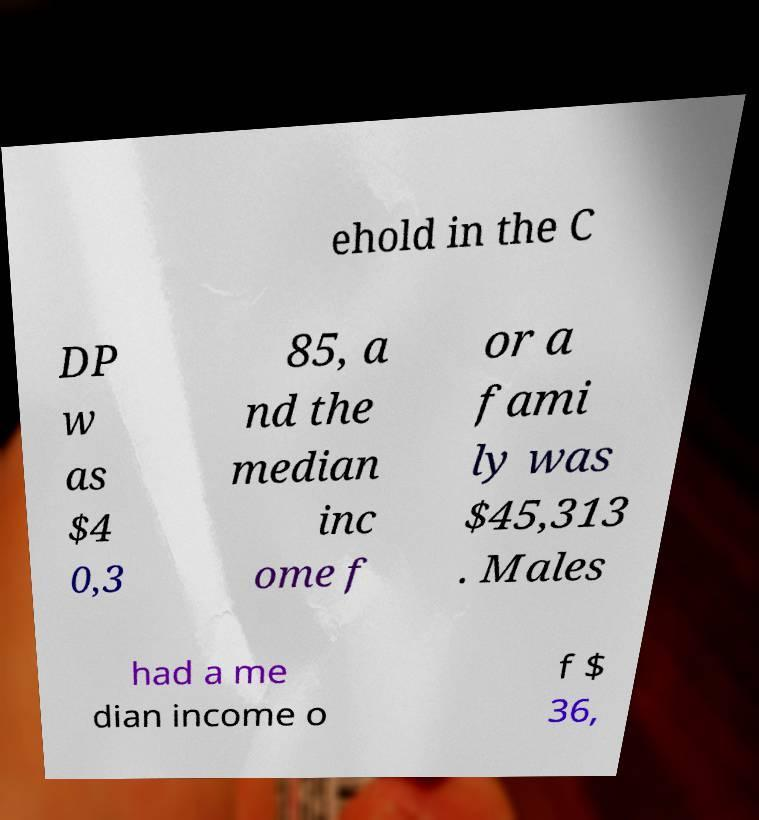What messages or text are displayed in this image? I need them in a readable, typed format. ehold in the C DP w as $4 0,3 85, a nd the median inc ome f or a fami ly was $45,313 . Males had a me dian income o f $ 36, 